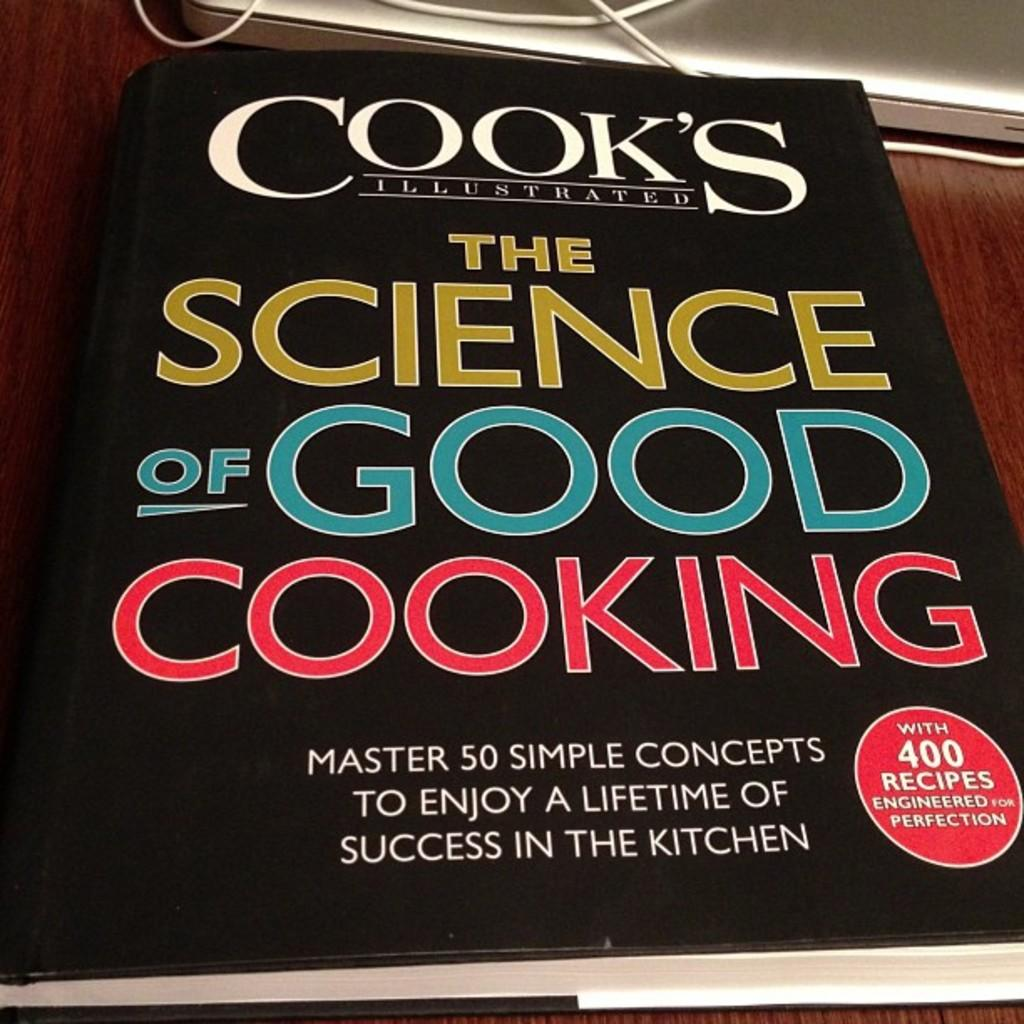<image>
Render a clear and concise summary of the photo. The Science of Good Cooking sits on the coffee table. 